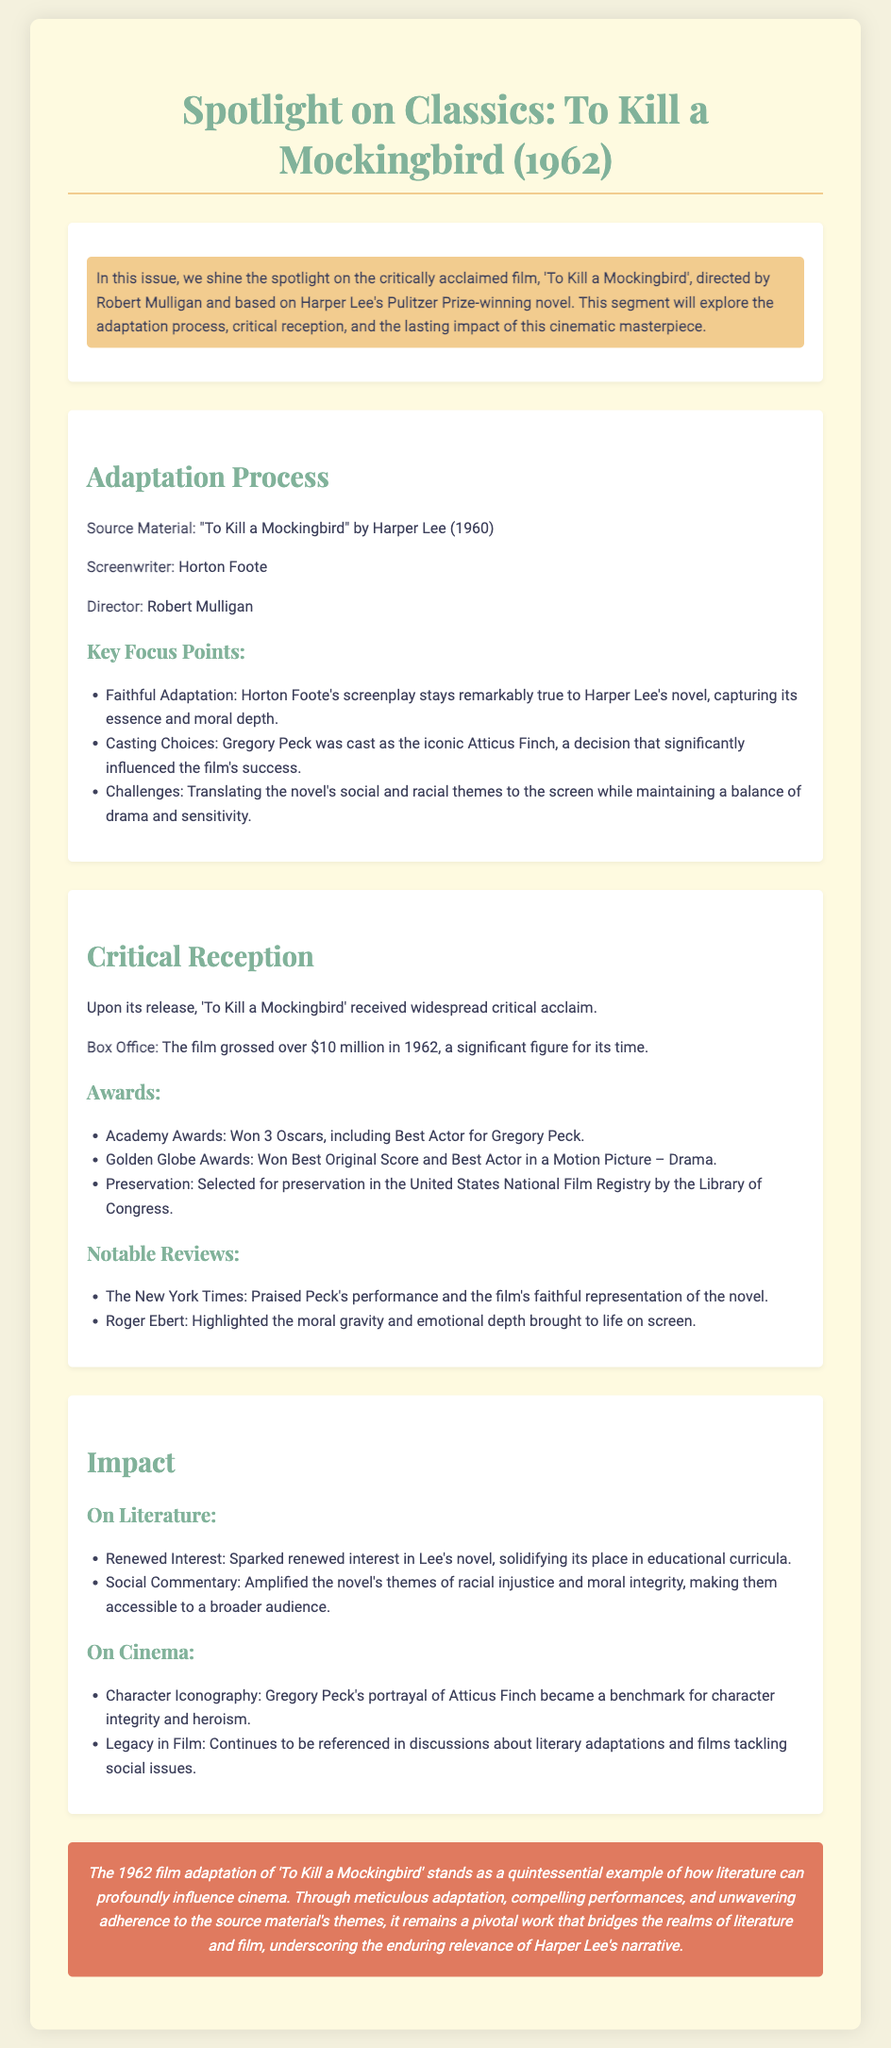What is the title of the film spotlighted in this issue? The title of the film is mentioned at the beginning of the document, "To Kill a Mockingbird".
Answer: To Kill a Mockingbird Who directed the film? The document provides the name of the director under the adaptation section.
Answer: Robert Mulligan What year was "To Kill a Mockingbird" released? The release year is found in the title of the document.
Answer: 1962 How many Academy Awards did the film win? The document lists the awards won, specifically stating "Won 3 Oscars".
Answer: 3 What was Gregory Peck's role in the film? The document specifically mentions he portrayed the iconic character Atticus Finch, representing heroism and integrity.
Answer: Atticus Finch What was the film's box office gross in 1962? The box office figure is provided as a significant financial detail.
Answer: Over $10 million What was the impact of the film on literature? The document discusses its influence, indicating it sparked renewed interest in Lee's novel.
Answer: Renewed interest What genre does "To Kill a Mockingbird" fall under? While not explicitly stated in this document, one can infer from the themes discussed.
Answer: Drama What type of score did the film win at the Golden Globe Awards? The document specifically indicates the type of award won for music.
Answer: Best Original Score 